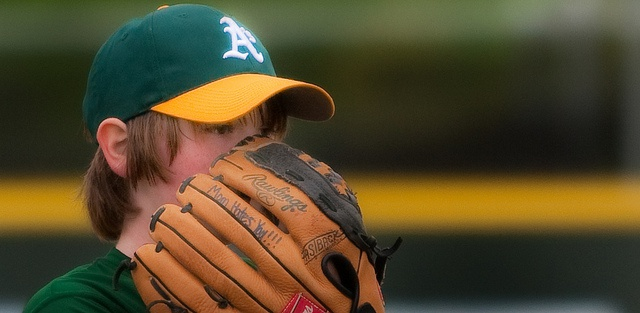Describe the objects in this image and their specific colors. I can see people in darkgreen, black, brown, and maroon tones and baseball glove in darkgreen, brown, black, tan, and maroon tones in this image. 